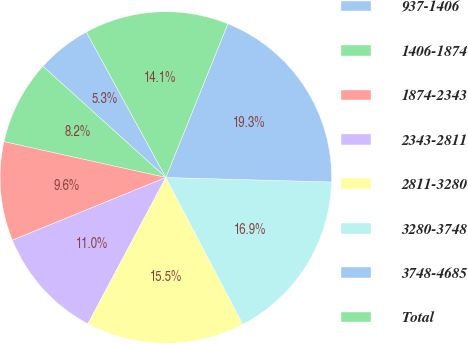<chart> <loc_0><loc_0><loc_500><loc_500><pie_chart><fcel>937-1406<fcel>1406-1874<fcel>1874-2343<fcel>2343-2811<fcel>2811-3280<fcel>3280-3748<fcel>3748-4685<fcel>Total<nl><fcel>5.33%<fcel>8.24%<fcel>9.64%<fcel>11.04%<fcel>15.48%<fcel>16.88%<fcel>19.33%<fcel>14.07%<nl></chart> 